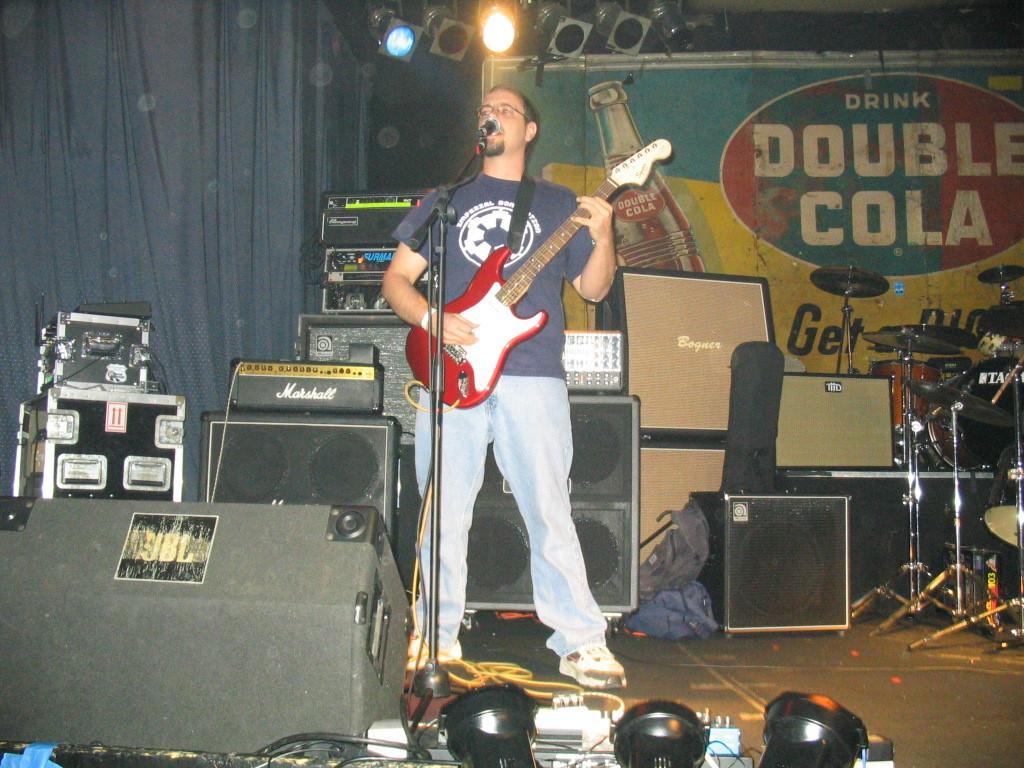How would you summarize this image in a sentence or two? In the center we can see one man standing,holding guitar. In front of him we can see microphone. And around him we can see some musical instruments and light,sheet,banner. 